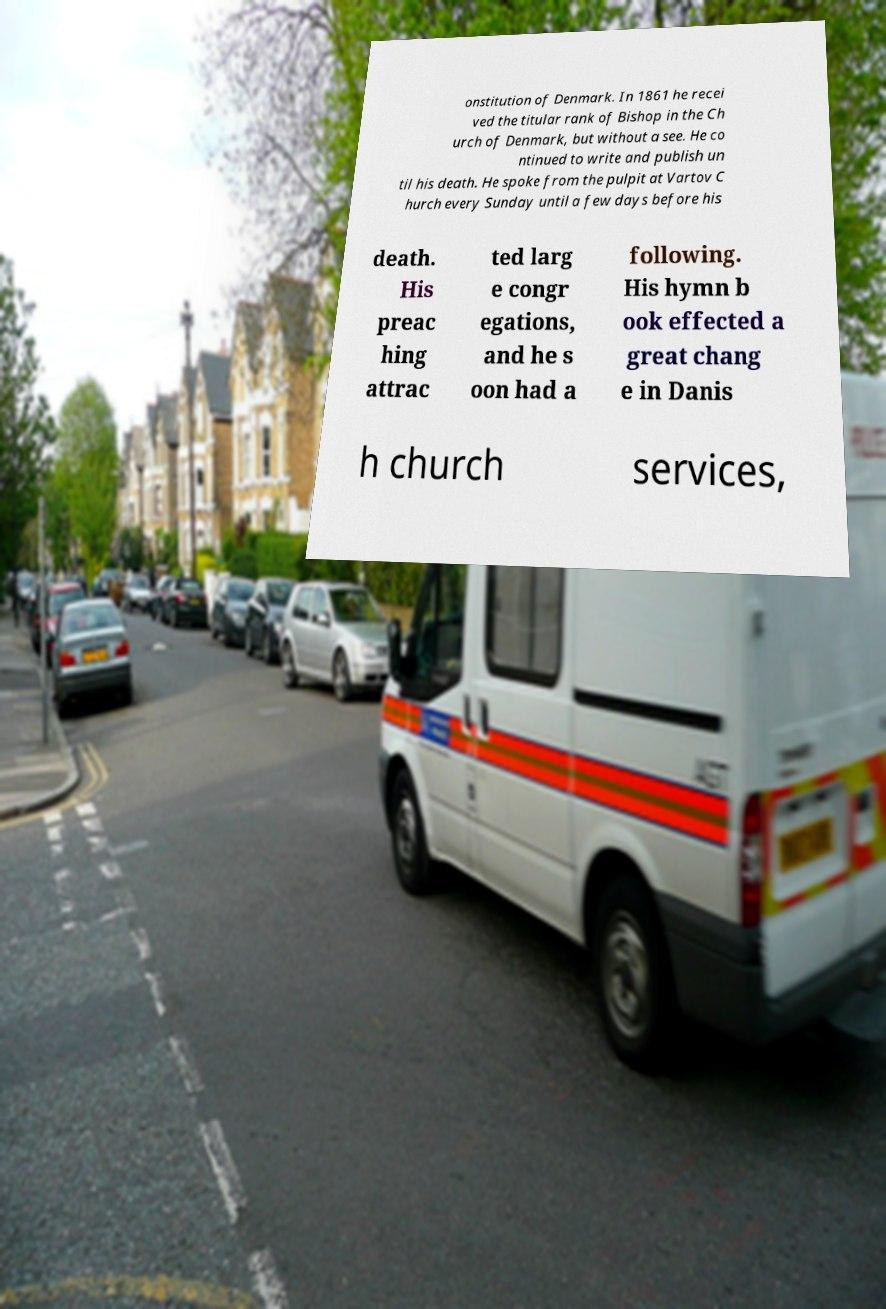Can you read and provide the text displayed in the image?This photo seems to have some interesting text. Can you extract and type it out for me? onstitution of Denmark. In 1861 he recei ved the titular rank of Bishop in the Ch urch of Denmark, but without a see. He co ntinued to write and publish un til his death. He spoke from the pulpit at Vartov C hurch every Sunday until a few days before his death. His preac hing attrac ted larg e congr egations, and he s oon had a following. His hymn b ook effected a great chang e in Danis h church services, 